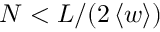<formula> <loc_0><loc_0><loc_500><loc_500>N < L / ( 2 \left < w \right > )</formula> 